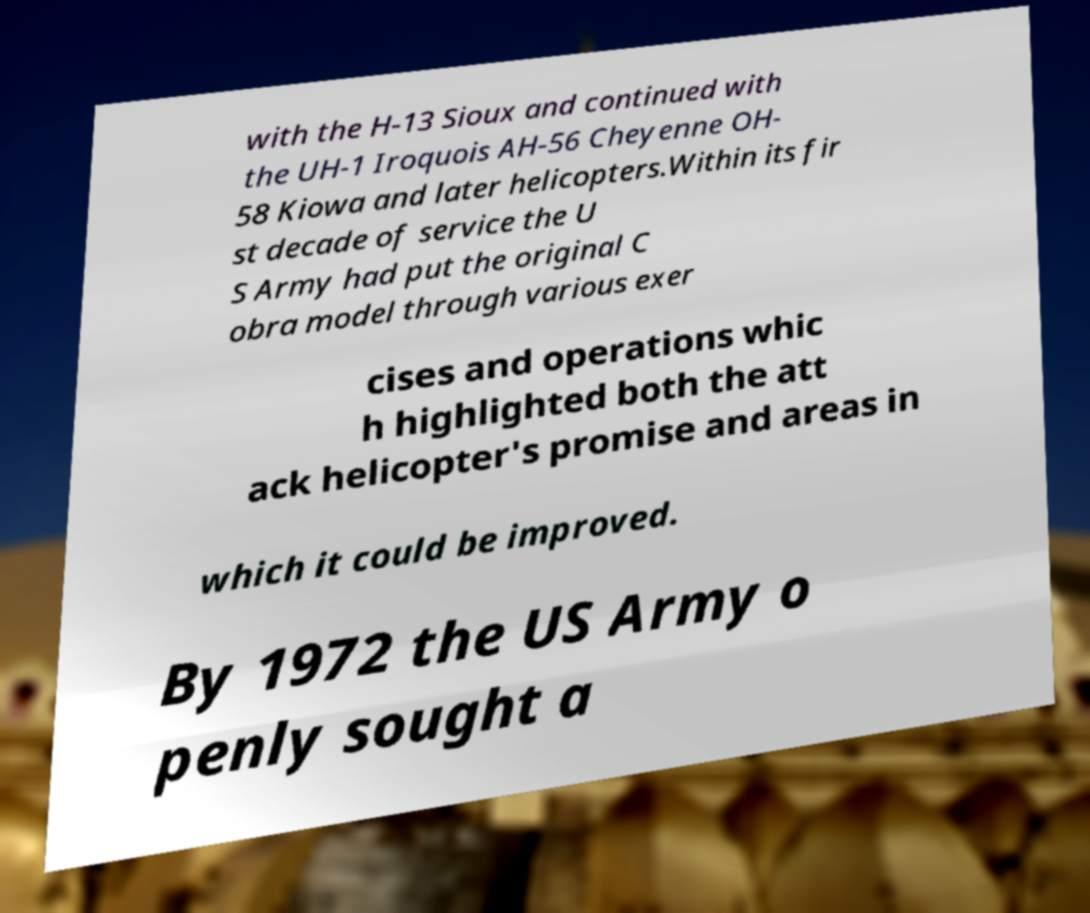Please identify and transcribe the text found in this image. with the H-13 Sioux and continued with the UH-1 Iroquois AH-56 Cheyenne OH- 58 Kiowa and later helicopters.Within its fir st decade of service the U S Army had put the original C obra model through various exer cises and operations whic h highlighted both the att ack helicopter's promise and areas in which it could be improved. By 1972 the US Army o penly sought a 